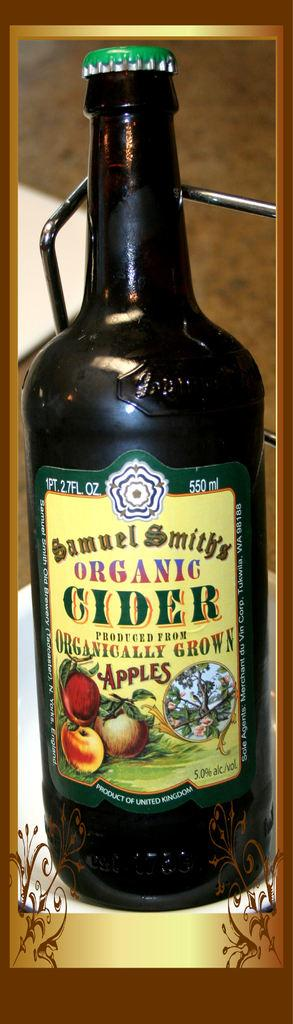<image>
Offer a succinct explanation of the picture presented. A bottle of Samuel Smith's Organic Cider, produced from organically grown apples. 